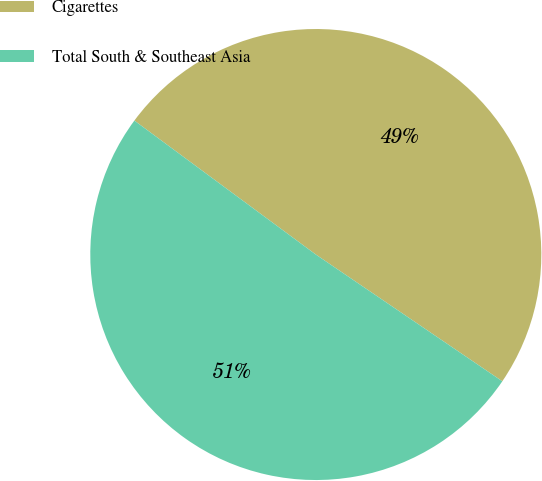Convert chart to OTSL. <chart><loc_0><loc_0><loc_500><loc_500><pie_chart><fcel>Cigarettes<fcel>Total South & Southeast Asia<nl><fcel>49.38%<fcel>50.62%<nl></chart> 